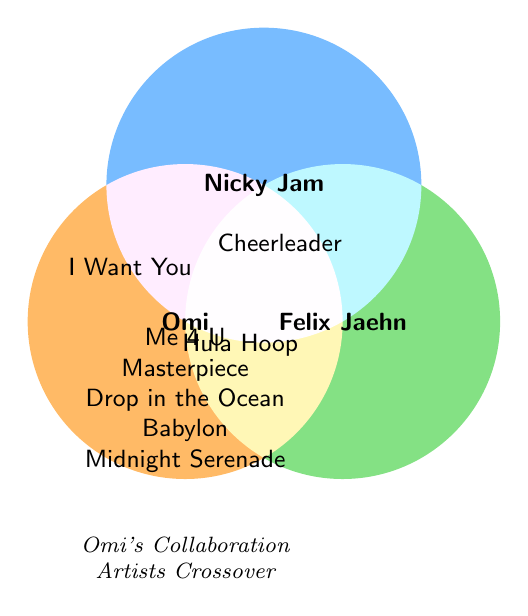How many songs are exclusively Omi's without any collaborations? The figure shows a list of songs within Omi's circle without overlap from other circles. These include "Me 4 U," "Masterpiece," "Drop in the Ocean," "Babylon," and "Midnight Serenade.” Counting these songs gives us five.
Answer: Five Which song has Omi collaborated on with both Nicky Jam and Felix Jaehn? Looking at the overlapping areas, "Cheerleader" is situated where all three artists' circles intersect, indicating a collaboration among Omi, Nicky Jam, and Felix Jaehn.
Answer: Cheerleader What songs has Omi done featuring Nicky Jam, but not Felix Jaehn? We need to look at the overlap between Omi's and Nicky Jam's circles but not Felix Jaehn's. The song listed in that shared space is "I Want You."
Answer: I Want You What songs does Felix Jaehn appear on? Felix Jaehn's circle contains overlaps with Omi's circle. The songs here include "Cheerleader" and "Hula Hoop.”
Answer: Cheerleader, Hula Hoop How many songs does Omi have that are collaborations? The collaborations include overlaps with other artists. "Cheerleader" with both Nicky Jam and Felix Jaehn, "I Want You" with Nicky Jam, and "Hula Hoop" with Felix Jaehn. There are three collaborative songs.
Answer: Three Which artist has the most collaborations with Omi? Nicky Jam has collaborations on "Cheerleader" and "I Want You," and Felix Jaehn has collaborations on "Cheerleader" and "Hula Hoop." Both Nicky Jam and Felix Jaehn are tied with two songs each.
Answer: Tied baina Nicky Jam and Felix Jaehn How many exclusive areas are present in the diagram? There are three exclusive areas corresponding to each artist and no overlap with others: Omi, Nicky Jam, and Felix Jaehn's exclusive areas. Counting them gives us three.
Answer: Three Does Felix Jaehn have any exclusive songs? The figure shows Felix Jaehn overlaps only with Omi and Nicky Jam's circles, implying there are no songs exclusively Felix Jaehn's.
Answer: No Which song indicates a collaboration between Nicky Jam and Felix Jaehn but not Omi? Looking at the figure, there is no area where only Nicky Jam and Felix Jaehn overlap, implying there are no such collaborations without Omi.
Answer: None 